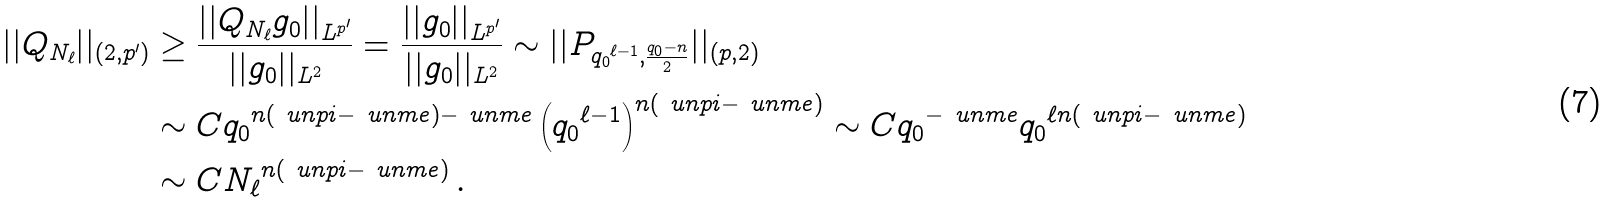<formula> <loc_0><loc_0><loc_500><loc_500>| | Q _ { N _ { \ell } } | | _ { \left ( 2 , { p ^ { \prime } } \right ) } & \geq \frac { | | Q _ { N _ { \ell } } g _ { 0 } | | _ { L ^ { p ^ { \prime } } } } { | | g _ { 0 } | | _ { L ^ { 2 } } } = \frac { | | g _ { 0 } | | _ { L ^ { p ^ { \prime } } } } { | | g _ { 0 } | | _ { L ^ { 2 } } } \sim | | P _ { { q _ { 0 } } ^ { \ell - 1 } , { \frac { { q _ { 0 } } - n } { 2 } } } | | _ { ( p , 2 ) } \\ & \sim C { q _ { 0 } } ^ { n ( \ u n p i - \ u n m e ) - \ u n m e } \left ( { { q _ { 0 } } ^ { \ell - 1 } } \right ) ^ { n ( \ u n p i - \ u n m e ) } \sim C { q _ { 0 } } ^ { - \ u n m e } { q _ { 0 } } ^ { \ell n ( \ u n p i - \ u n m e ) } \\ & \sim C { N _ { \ell } } ^ { n ( \ u n p i - \ u n m e ) } \, . \\</formula> 